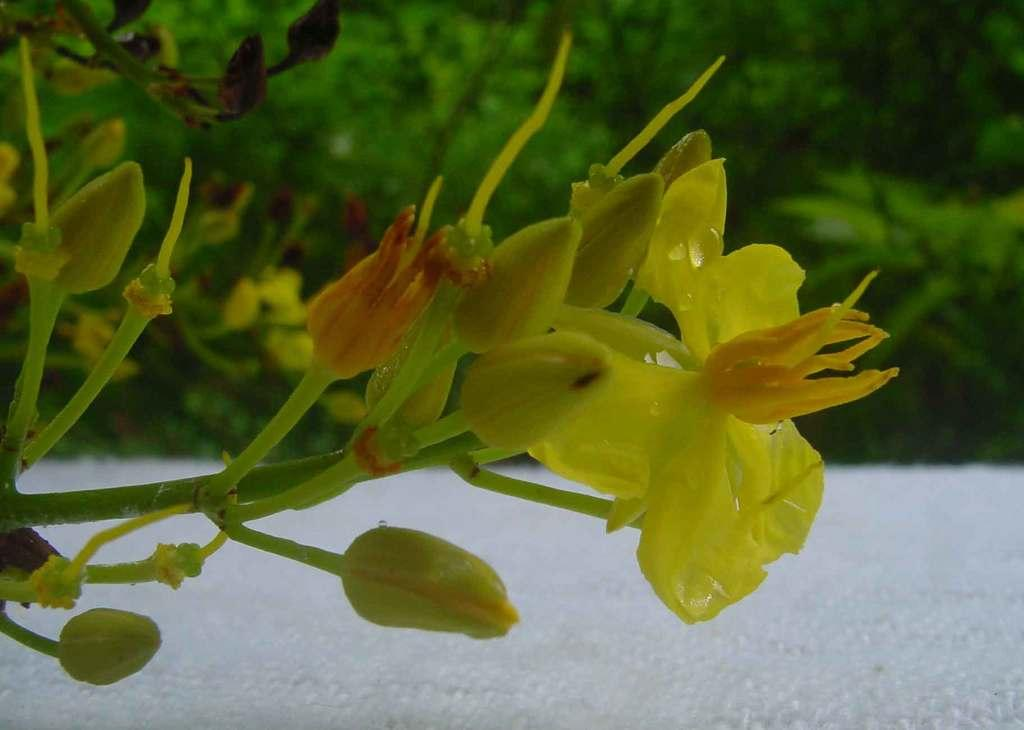What is the main subject of the image? The main subject of the image is a part of a plant. What is the surface beneath the plant? There is a white surface under the plant. Can you describe the background of the image? The background of the image is blurry. What type of toy can be seen on the chin of the person in the image? There is no person or toy present in the image; it features a part of a plant and a white surface. 